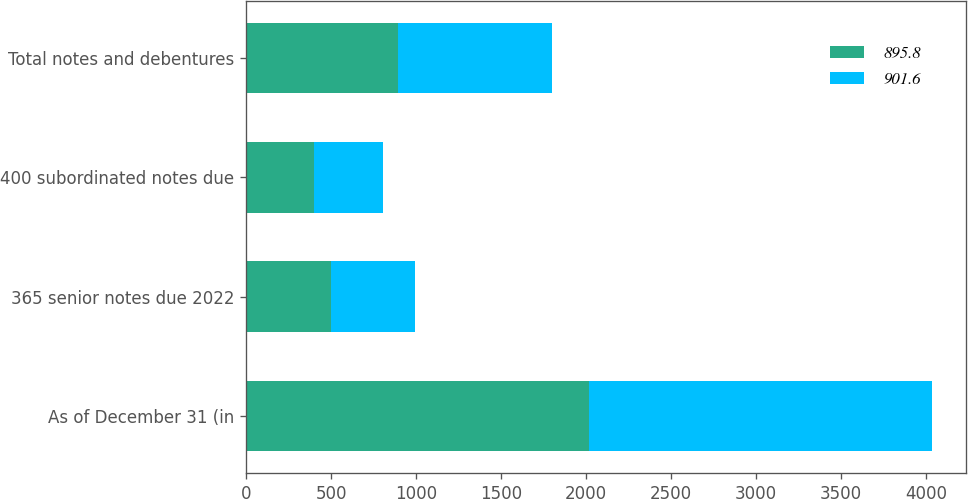Convert chart to OTSL. <chart><loc_0><loc_0><loc_500><loc_500><stacked_bar_chart><ecel><fcel>As of December 31 (in<fcel>365 senior notes due 2022<fcel>400 subordinated notes due<fcel>Total notes and debentures<nl><fcel>895.8<fcel>2018<fcel>497.7<fcel>398.1<fcel>895.8<nl><fcel>901.6<fcel>2017<fcel>497.1<fcel>404.5<fcel>901.6<nl></chart> 